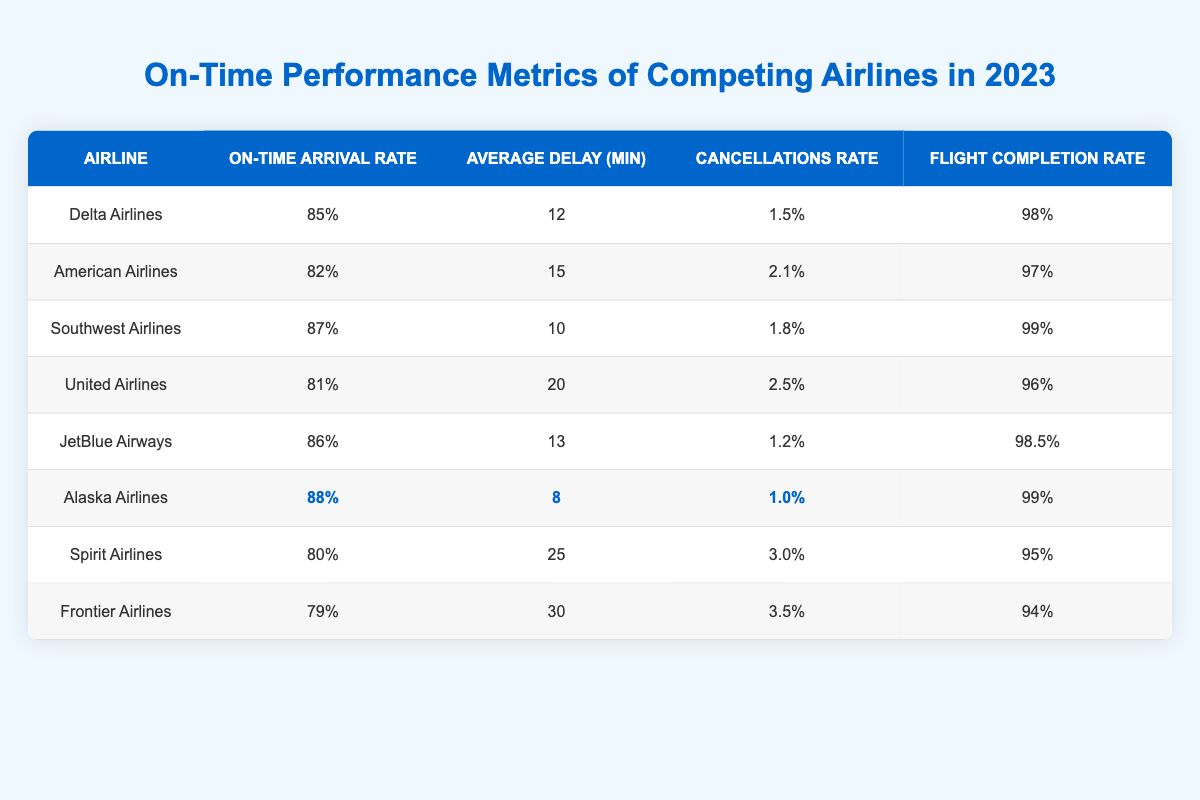What is the on-time arrival rate of Alaska Airlines? The table lists Alaska Airlines with an on-time arrival rate of 88% under the "On-Time Arrival Rate" column.
Answer: 88% Which airline has the highest flight completion rate? By comparing the values in the "Flight Completion Rate" column, Alaska Airlines has the highest value at 99%.
Answer: Alaska Airlines What is the average delay for Southwest Airlines? The "Average Delay (min)" column shows that Southwest Airlines has an average delay of 10 minutes.
Answer: 10 minutes Which airline has the lowest cancellations rate? Comparing the "Cancellations Rate" values, Alaska Airlines at 1.0% has the lowest rate.
Answer: Alaska Airlines What is the difference in average delay minutes between Delta Airlines and Frontier Airlines? Delta Airlines has an average delay of 12 minutes, while Frontier Airlines has an average delay of 30 minutes. The difference is 30 - 12 = 18 minutes.
Answer: 18 minutes What percentage of airlines listed have an on-time arrival rate of 85% or higher? There are 8 airlines total. The following have an on-time arrival rate of 85% or higher: Delta (85%), Southwest (87%), JetBlue (86%), and Alaska (88%). That's 4 airlines, so (4/8) * 100 = 50%.
Answer: 50% Is the average delay for Spirit Airlines greater than the average delay for American Airlines? Spirit Airlines has an average delay of 25 minutes, while American Airlines has 15 minutes. Since 25 > 15, the statement is true.
Answer: Yes What is the total percentage of cancellations from JetBlue Airways and United Airlines combined? The cancellations rates for JetBlue (1.2%) and United (2.5%) combine to 1.2 + 2.5 = 3.7%.
Answer: 3.7% Which airline has the best overall performance in terms of both on-time arrival and low cancellations? Alaska Airlines has the highest on-time arrival rate (88%) and the lowest cancellations rate (1.0%), making it the best performer in both metrics.
Answer: Alaska Airlines What is the median on-time arrival rate among the airlines listed? The sorted on-time arrival rates are 79%, 80%, 81%, 82%, 85%, 86%, 87%, 88%. The median, being the average of the 4th and 5th values (82% and 85%), is (82 + 85) / 2 = 83.5%.
Answer: 83.5% 